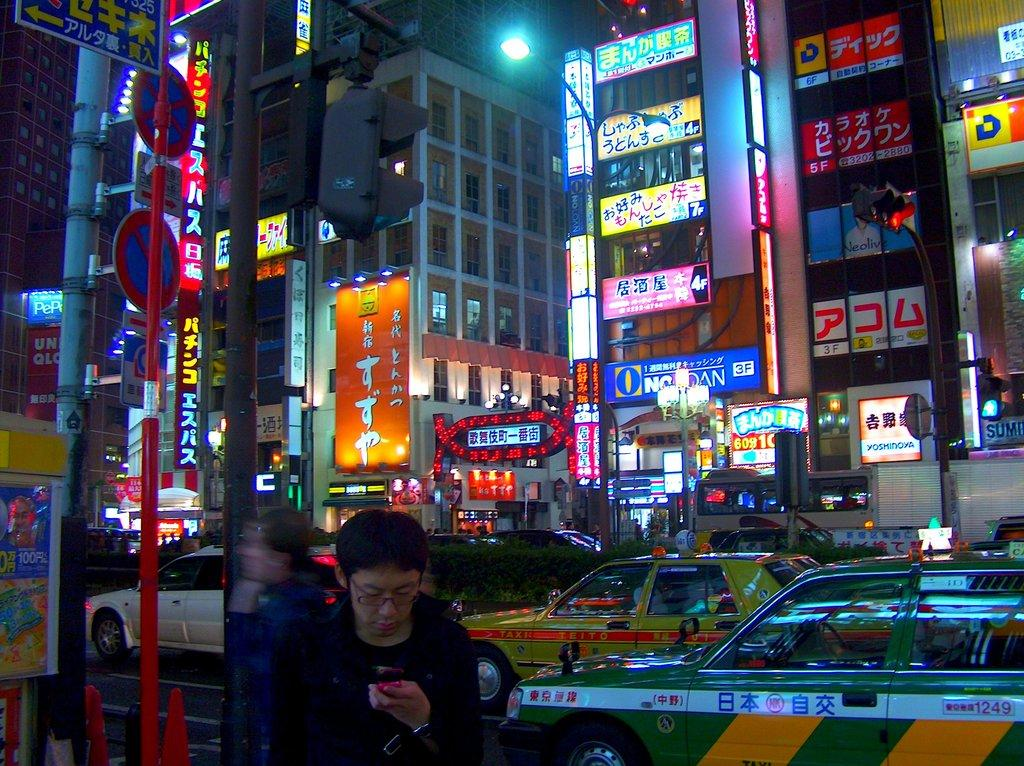<image>
Describe the image concisely. An asian metropolis with many signs in a foreign language, the only visible word in English is Yosminova. 